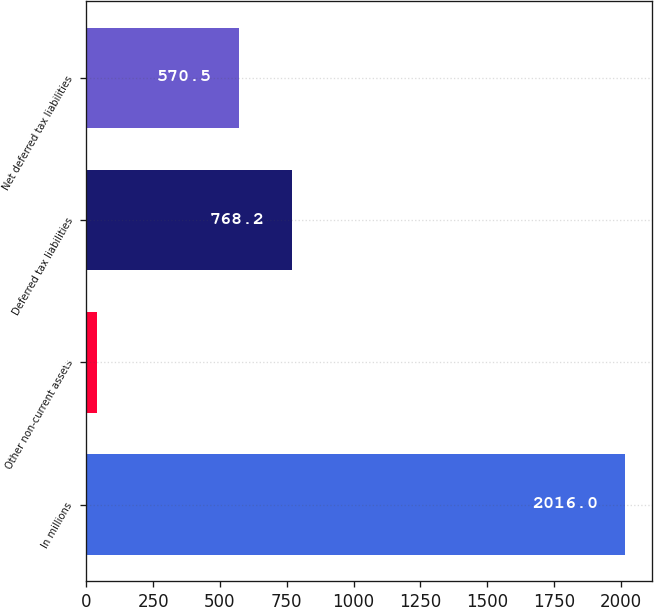<chart> <loc_0><loc_0><loc_500><loc_500><bar_chart><fcel>In millions<fcel>Other non-current assets<fcel>Deferred tax liabilities<fcel>Net deferred tax liabilities<nl><fcel>2016<fcel>39<fcel>768.2<fcel>570.5<nl></chart> 